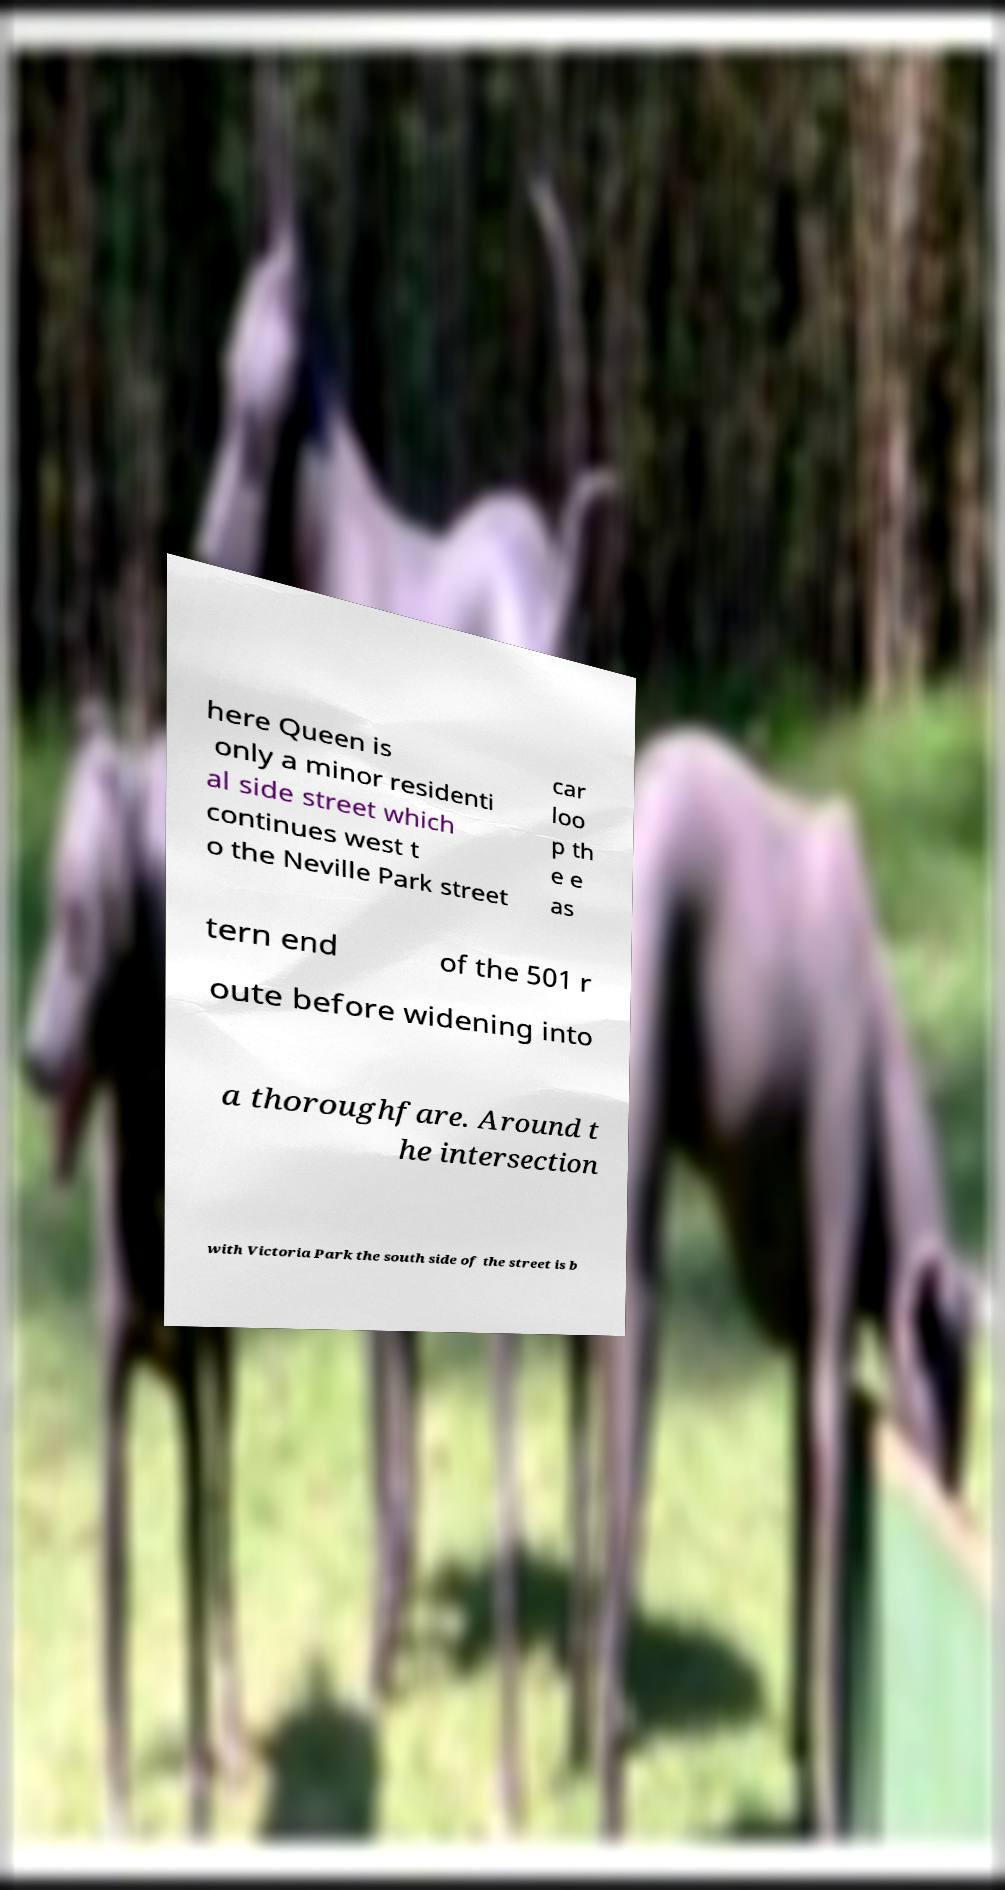For documentation purposes, I need the text within this image transcribed. Could you provide that? here Queen is only a minor residenti al side street which continues west t o the Neville Park street car loo p th e e as tern end of the 501 r oute before widening into a thoroughfare. Around t he intersection with Victoria Park the south side of the street is b 